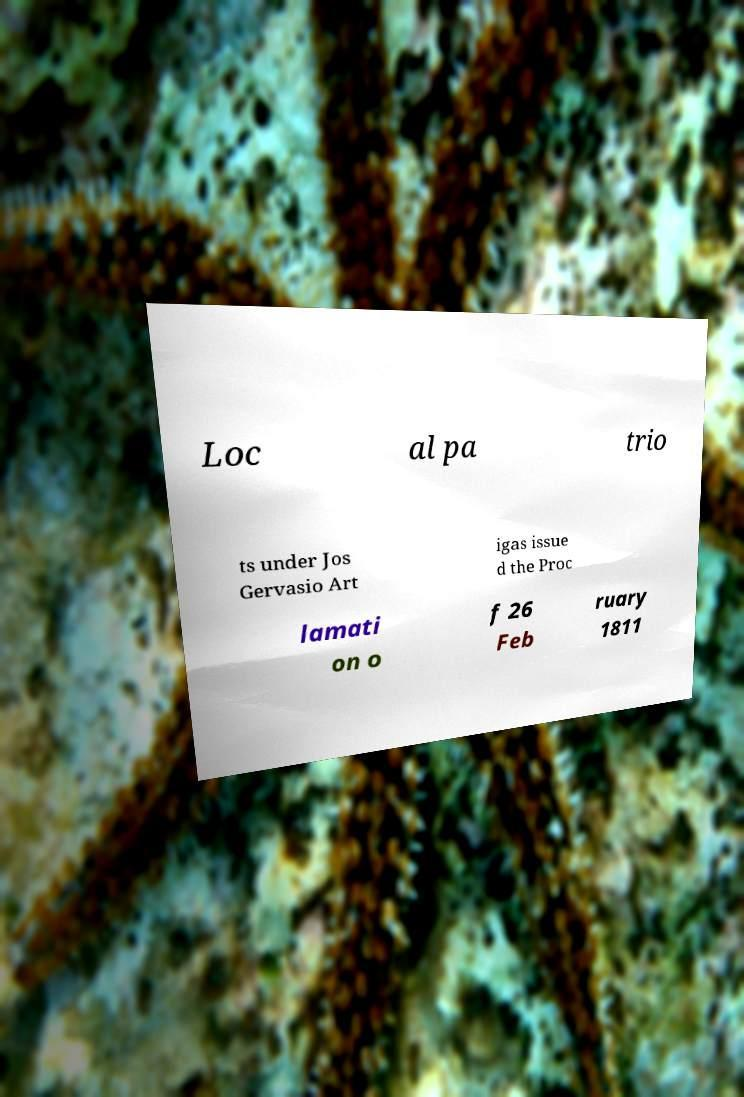Can you accurately transcribe the text from the provided image for me? Loc al pa trio ts under Jos Gervasio Art igas issue d the Proc lamati on o f 26 Feb ruary 1811 